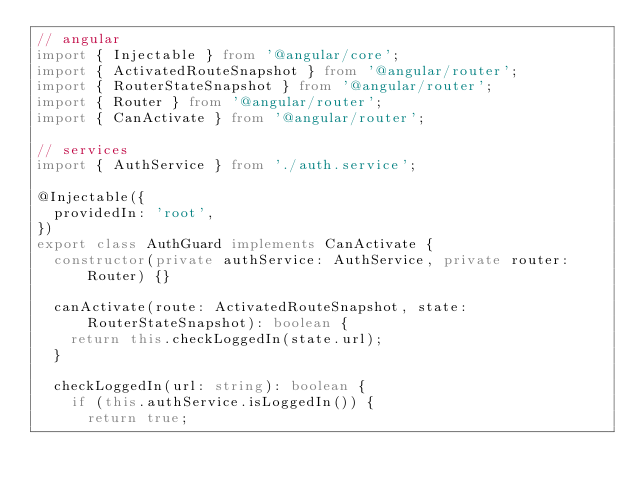Convert code to text. <code><loc_0><loc_0><loc_500><loc_500><_TypeScript_>// angular
import { Injectable } from '@angular/core';
import { ActivatedRouteSnapshot } from '@angular/router';
import { RouterStateSnapshot } from '@angular/router';
import { Router } from '@angular/router';
import { CanActivate } from '@angular/router';

// services
import { AuthService } from './auth.service';

@Injectable({
  providedIn: 'root',
})
export class AuthGuard implements CanActivate {
  constructor(private authService: AuthService, private router: Router) {}

  canActivate(route: ActivatedRouteSnapshot, state: RouterStateSnapshot): boolean {
    return this.checkLoggedIn(state.url);
  }

  checkLoggedIn(url: string): boolean {
    if (this.authService.isLoggedIn()) {
      return true;</code> 